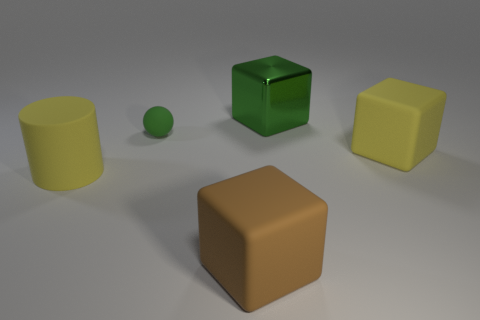Add 1 big blocks. How many objects exist? 6 Subtract all cylinders. How many objects are left? 4 Subtract 1 yellow blocks. How many objects are left? 4 Subtract all big blue rubber cylinders. Subtract all green objects. How many objects are left? 3 Add 1 big metallic things. How many big metallic things are left? 2 Add 5 large rubber spheres. How many large rubber spheres exist? 5 